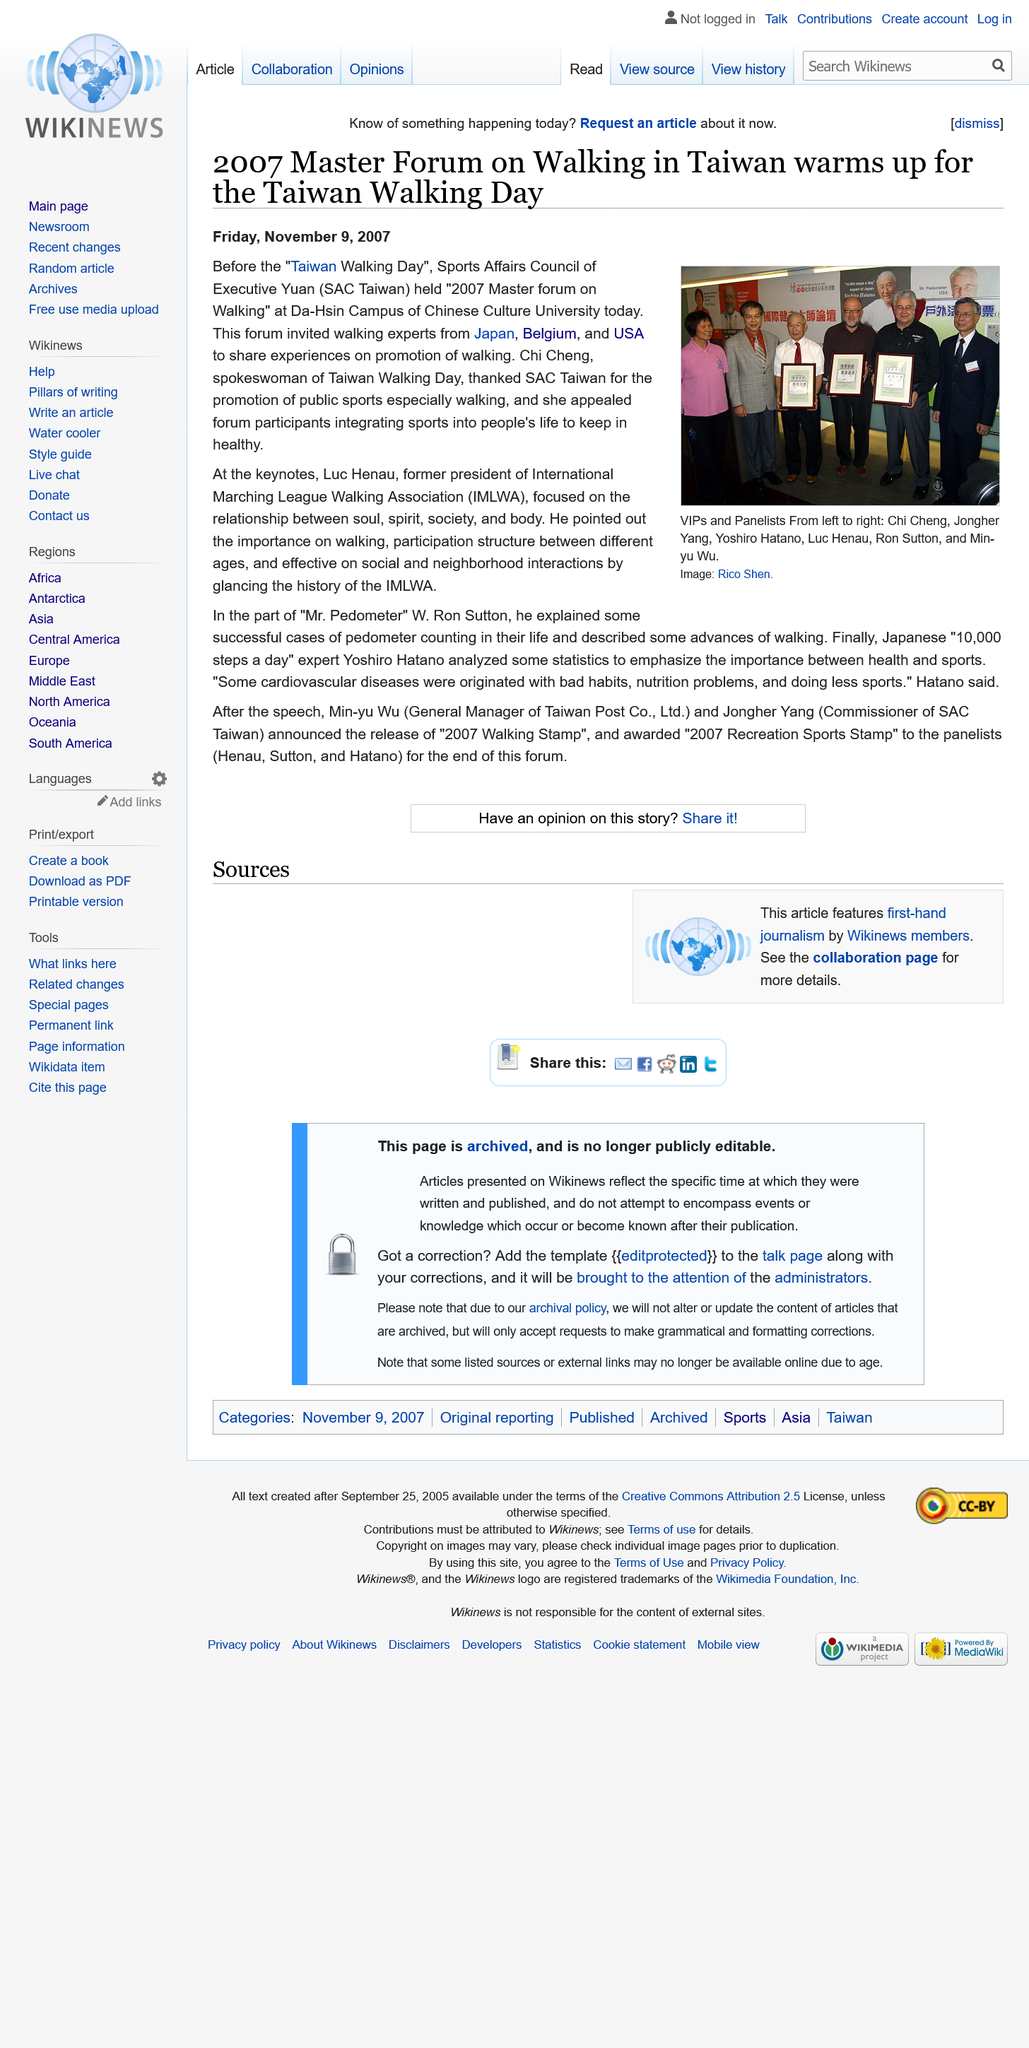Specify some key components in this picture. The 2007 Master Forum on Walking was held at the Da-Hsin Campus of the Chinese Culture University. The abbreviation IMLWA stands for the International Marching League Walking Association. 